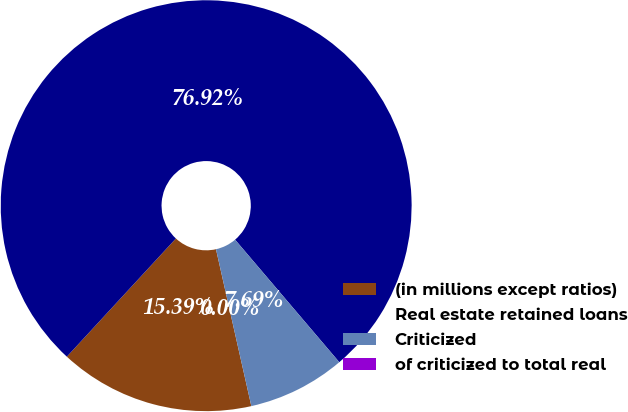<chart> <loc_0><loc_0><loc_500><loc_500><pie_chart><fcel>(in millions except ratios)<fcel>Real estate retained loans<fcel>Criticized<fcel>of criticized to total real<nl><fcel>15.39%<fcel>76.92%<fcel>7.69%<fcel>0.0%<nl></chart> 